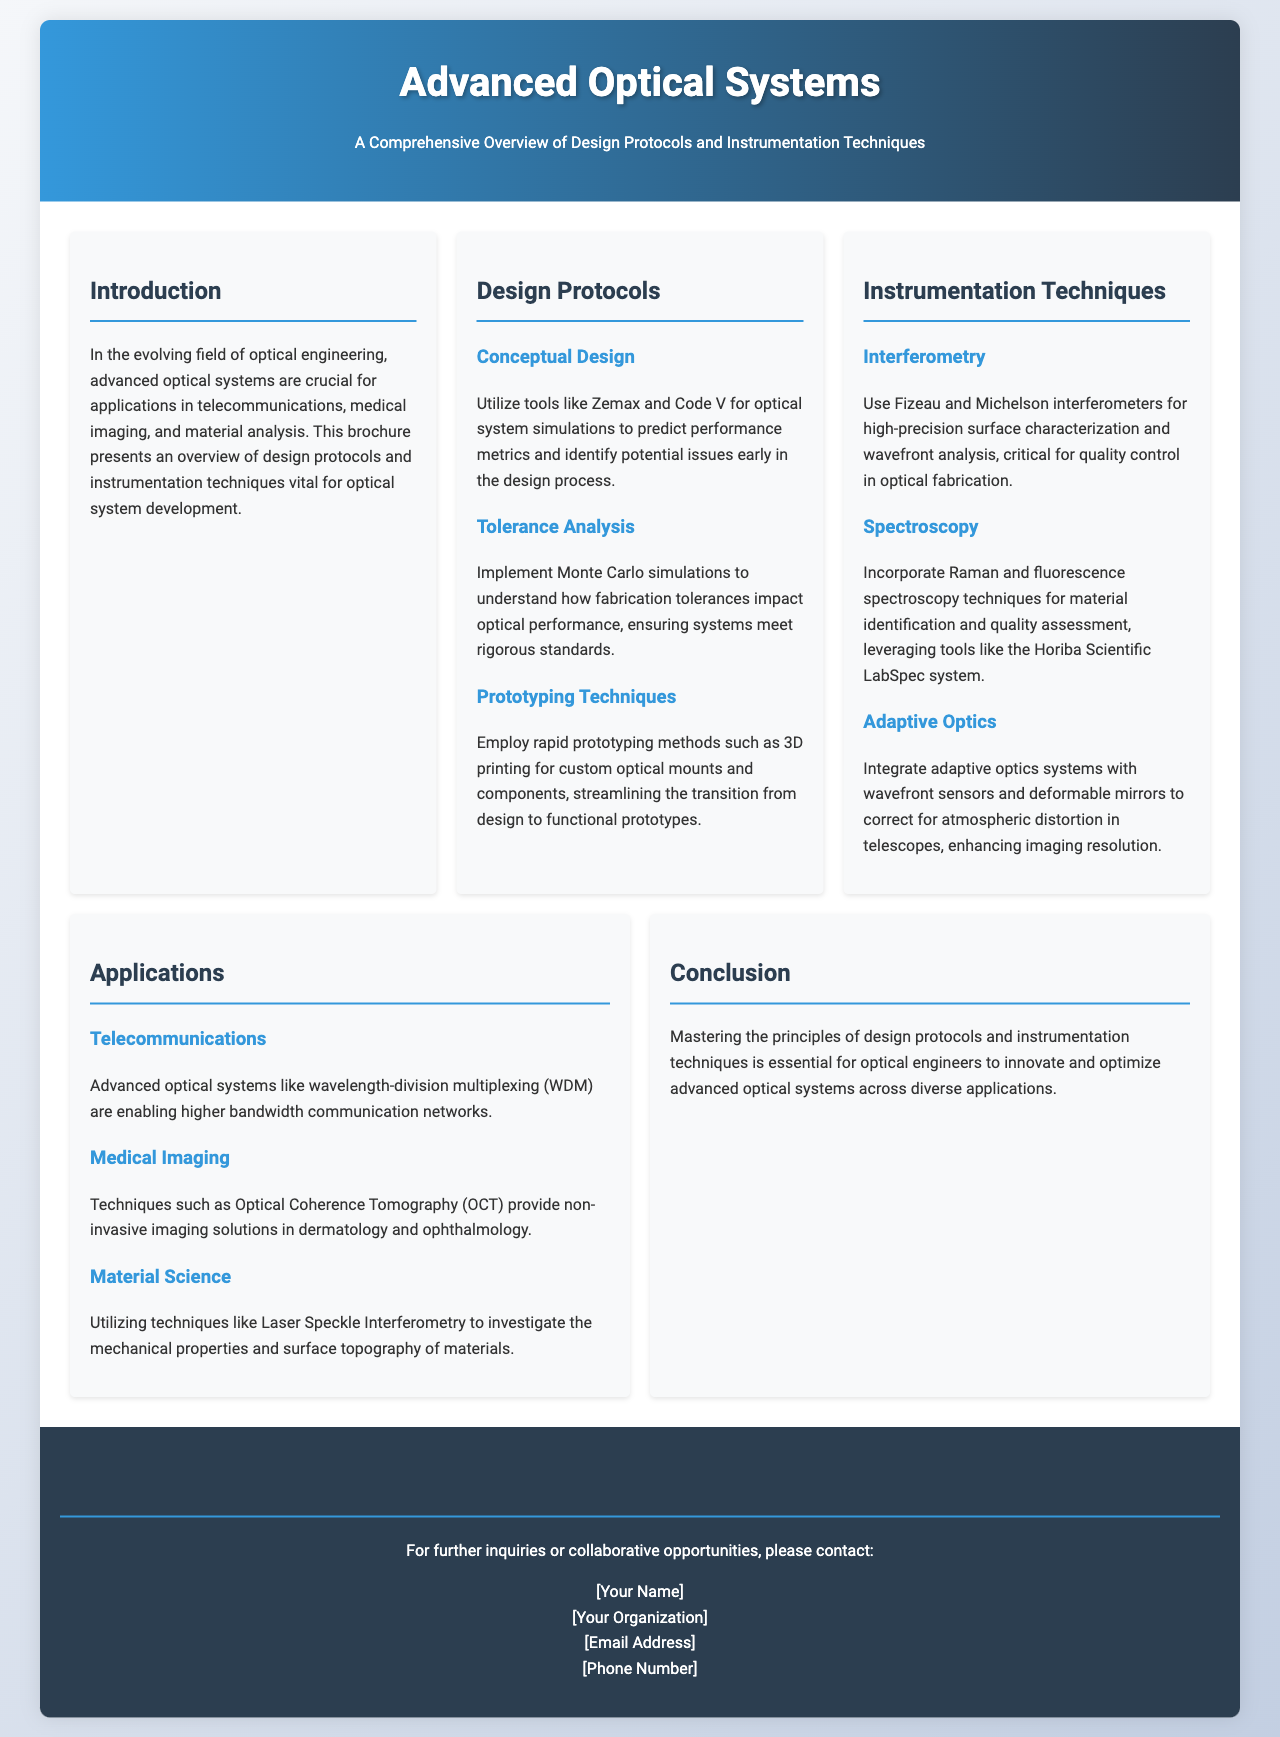What are the applications of advanced optical systems? The brochure lists several applications such as telecommunications, medical imaging, and material science.
Answer: Telecommunications, medical imaging, material science What are the three design protocols mentioned? The document outlines conceptual design, tolerance analysis, and prototyping techniques as the three main design protocols.
Answer: Conceptual design, tolerance analysis, prototyping techniques Which simulation tools are recommended for conceptual design? Zemax and Code V are specifically mentioned as tools for optical system simulations in the conceptual design phase.
Answer: Zemax, Code V What technique is used for high-precision surface characterization? The brochure mentions interferometry techniques, specifically Fizeau and Michelson interferometers, for characterizing surfaces.
Answer: Fizeau and Michelson interferometers Which spectroscopy technique is utilized for material identification? Raman and fluorescence spectroscopy techniques are highlighted as methods for material identification.
Answer: Raman and fluorescence spectroscopy How does adaptive optics enhance imaging resolution? The document explains that adaptive optics systems with wavefront sensors and deformable mirrors correct atmospheric distortion to enhance imaging.
Answer: Correct atmospheric distortion What is Optical Coherence Tomography (OCT) used for? OCT is described as providing non-invasive imaging solutions, particularly in dermatology and ophthalmology.
Answer: Non-invasive imaging solutions What should optical engineers master according to the conclusion? The conclusion emphasizes mastering design protocols and instrumentation techniques to innovate in optical systems.
Answer: Design protocols and instrumentation techniques What type of brochure is this document? The content and structure of the document indicate it is a brochure providing an overview of advanced optical systems.
Answer: Overview of advanced optical systems 